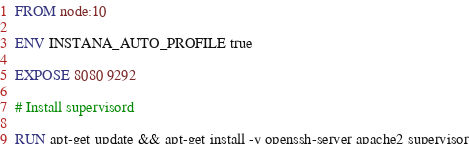<code> <loc_0><loc_0><loc_500><loc_500><_Dockerfile_>FROM node:10

ENV INSTANA_AUTO_PROFILE true

EXPOSE 8080 9292

# Install supervisord

RUN apt-get update && apt-get install -y openssh-server apache2 supervisor</code> 